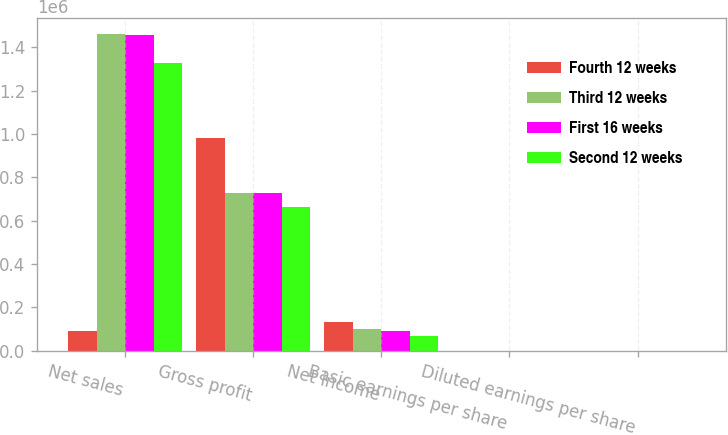<chart> <loc_0><loc_0><loc_500><loc_500><stacked_bar_chart><ecel><fcel>Net sales<fcel>Gross profit<fcel>Net income<fcel>Basic earnings per share<fcel>Diluted earnings per share<nl><fcel>Fourth 12 weeks<fcel>89503<fcel>980673<fcel>133506<fcel>1.83<fcel>1.79<nl><fcel>Third 12 weeks<fcel>1.46098e+06<fcel>728858<fcel>99606<fcel>1.36<fcel>1.34<nl><fcel>First 16 weeks<fcel>1.45753e+06<fcel>725350<fcel>89503<fcel>1.22<fcel>1.21<nl><fcel>Second 12 weeks<fcel>1.3292e+06<fcel>663155<fcel>65055<fcel>0.89<fcel>0.88<nl></chart> 